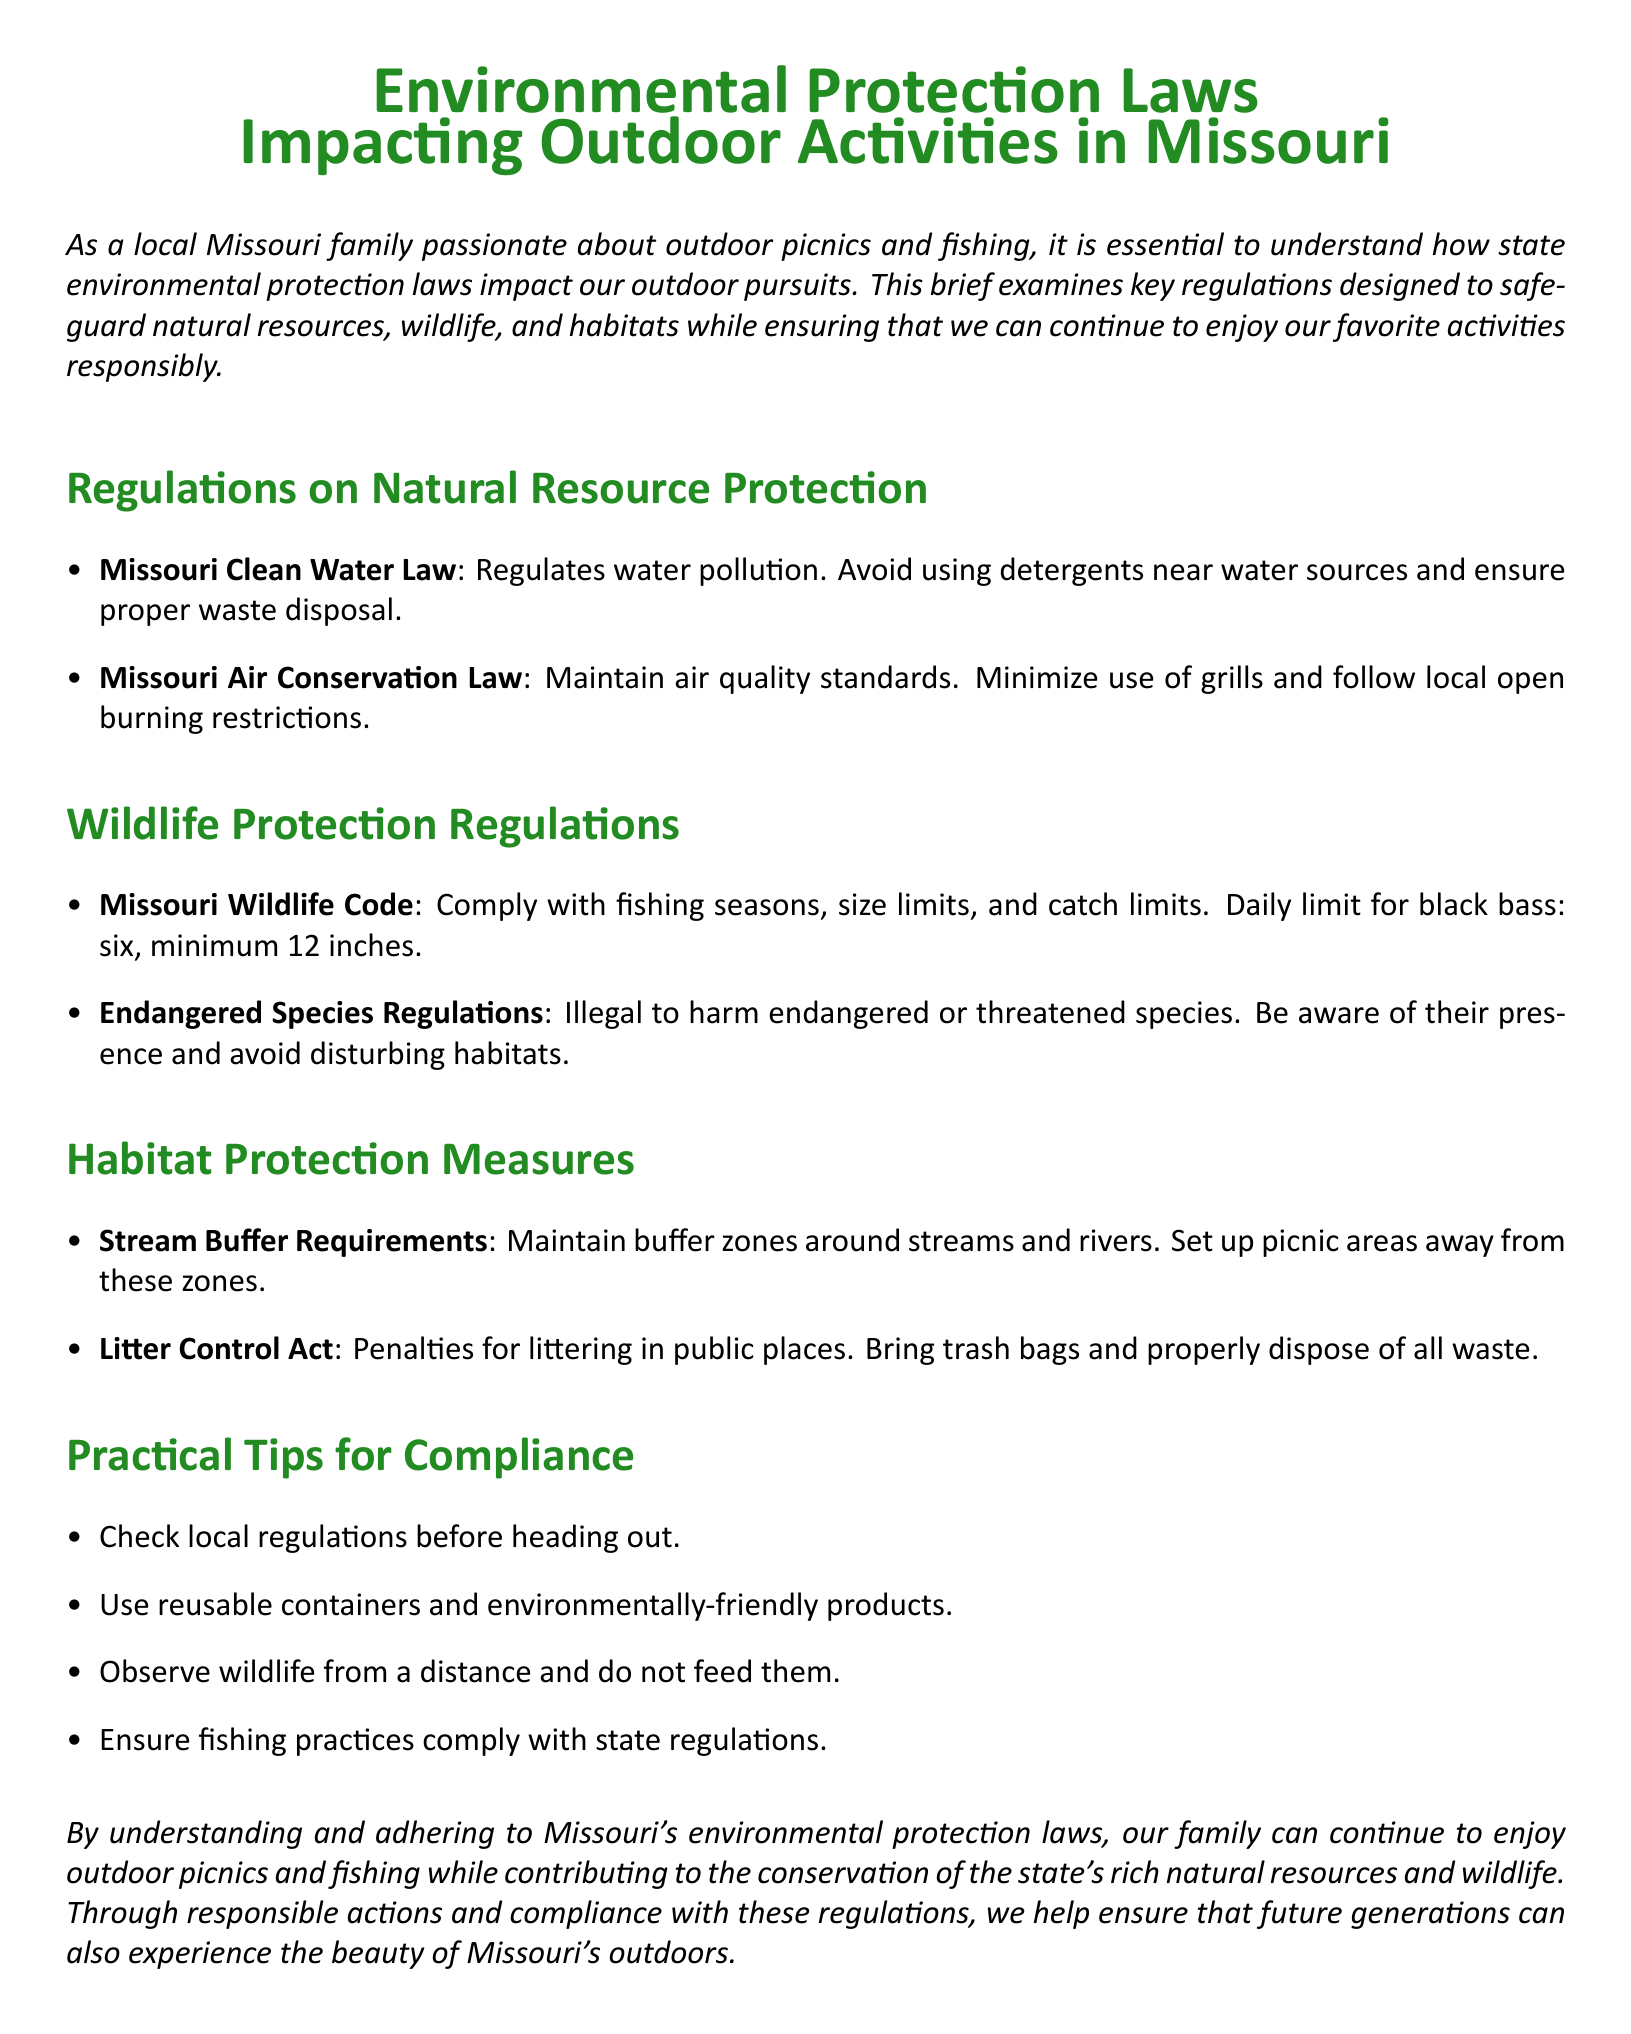What is the law that regulates water pollution in Missouri? The document lists the Missouri Clean Water Law as the regulation for water pollution, which includes guidelines on avoiding detergents near water sources.
Answer: Missouri Clean Water Law What is the daily limit for black bass fishing in Missouri? The document specifies that the daily limit for black bass is six fish, with a minimum size requirement of 12 inches.
Answer: Six What should families do to comply with pollution regulations while grilling? According to the Missouri Air Conservation Law mentioned in the document, families should minimize the use of grills and adhere to local open burning restrictions.
Answer: Minimize use of grills What is a recommended practice regarding littering? The document indicates that bringing trash bags and properly disposing of waste is essential to comply with the Litter Control Act and avoid penalties for littering.
Answer: Bring trash bags What is the purpose of stream buffer requirements? The document explains that maintaining buffer zones around streams and rivers helps to protect natural habitats and resources, which indirectly relates to family picnic practices.
Answer: Habitat protection What should families check before going out for outdoor activities? The brief suggests that families should check local regulations to ensure compliance with environmental laws before heading out for outdoor activities.
Answer: Local regulations How can families observe wildlife responsibly? The document advises families to observe wildlife from a distance and not to feed them, which is crucial for wildlife protection.
Answer: Observe from a distance What is emphasized for fishing practices in Missouri? The document stresses compliance with state regulations regarding fishing to ensure responsible outdoor activities.
Answer: Compliance with regulations 